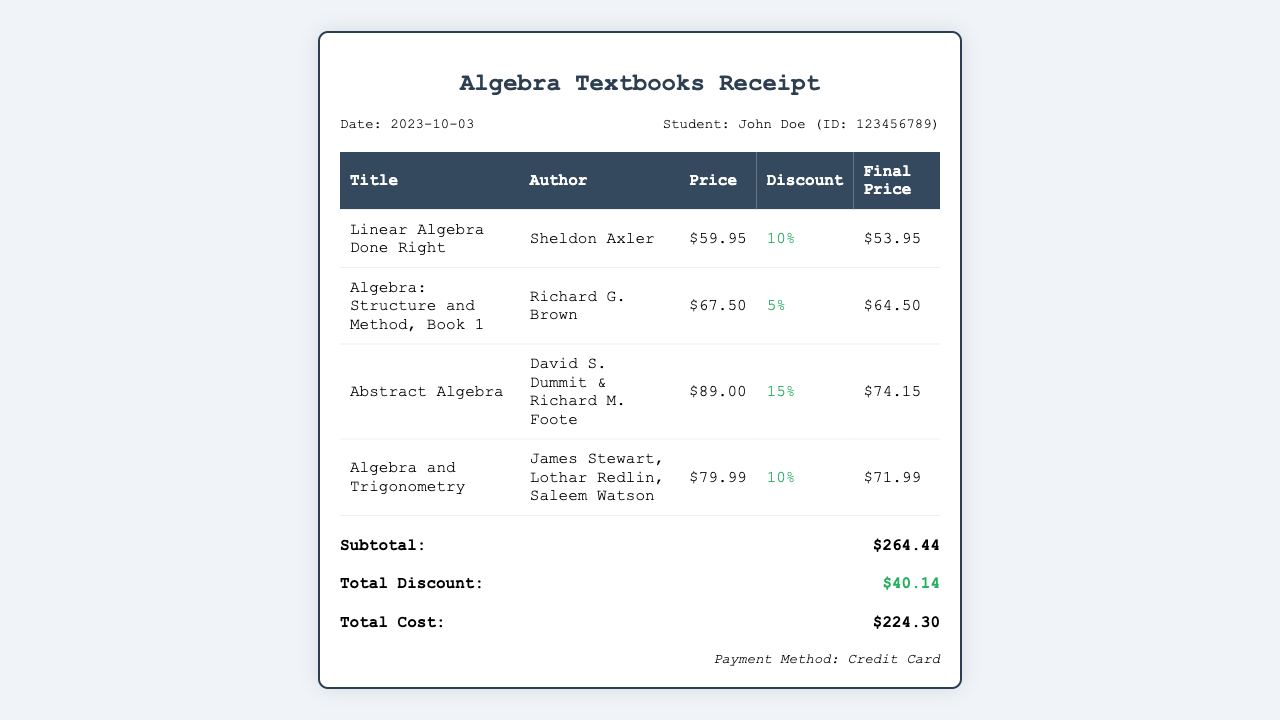What is the date of purchase? The date of purchase is listed at the top of the receipt.
Answer: 2023-10-03 Who is the student making the purchase? The student’s name and ID are provided in the receipt.
Answer: John Doe (ID: 123456789) What is the price of "Linear Algebra Done Right"? The price for this textbook is detailed in the receipt.
Answer: $59.95 What discount was applied to "Abstract Algebra"? The discount for this textbook is specified in the receipt table.
Answer: 15% What is the total discount amount? The total discount is calculated based on all individual discounts listed.
Answer: $40.14 What is the final price of "Algebra and Trigonometry"? The final price after discount is shown in the receipt.
Answer: $71.99 What is the subtotal of the purchase? The subtotal is the sum of all final prices before the total discount is applied.
Answer: $264.44 What method of payment was used? The method of payment is indicated at the bottom of the receipt.
Answer: Credit Card What is the total cost after discount? The total cost reflects the final amount owed after all discounts.
Answer: $224.30 